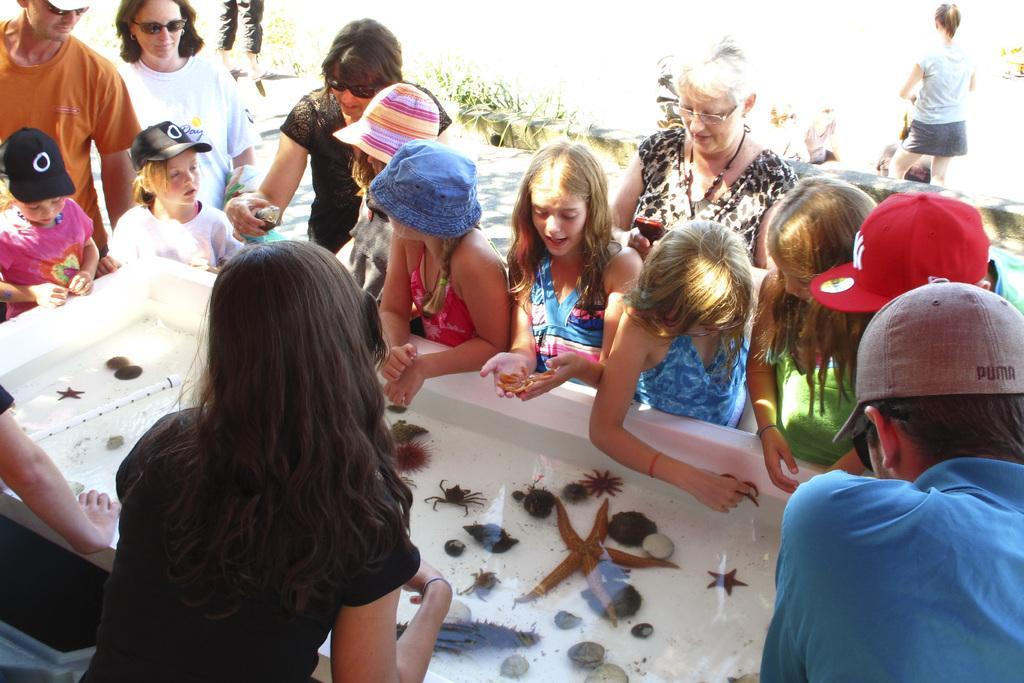How would you summarize this image in a sentence or two? This picture is clicked outside. In the center there is a bathtub containing marine creatures and water and we can see the group of people and group of kids standing on the ground. In the background we can see the plants and some other objects. 